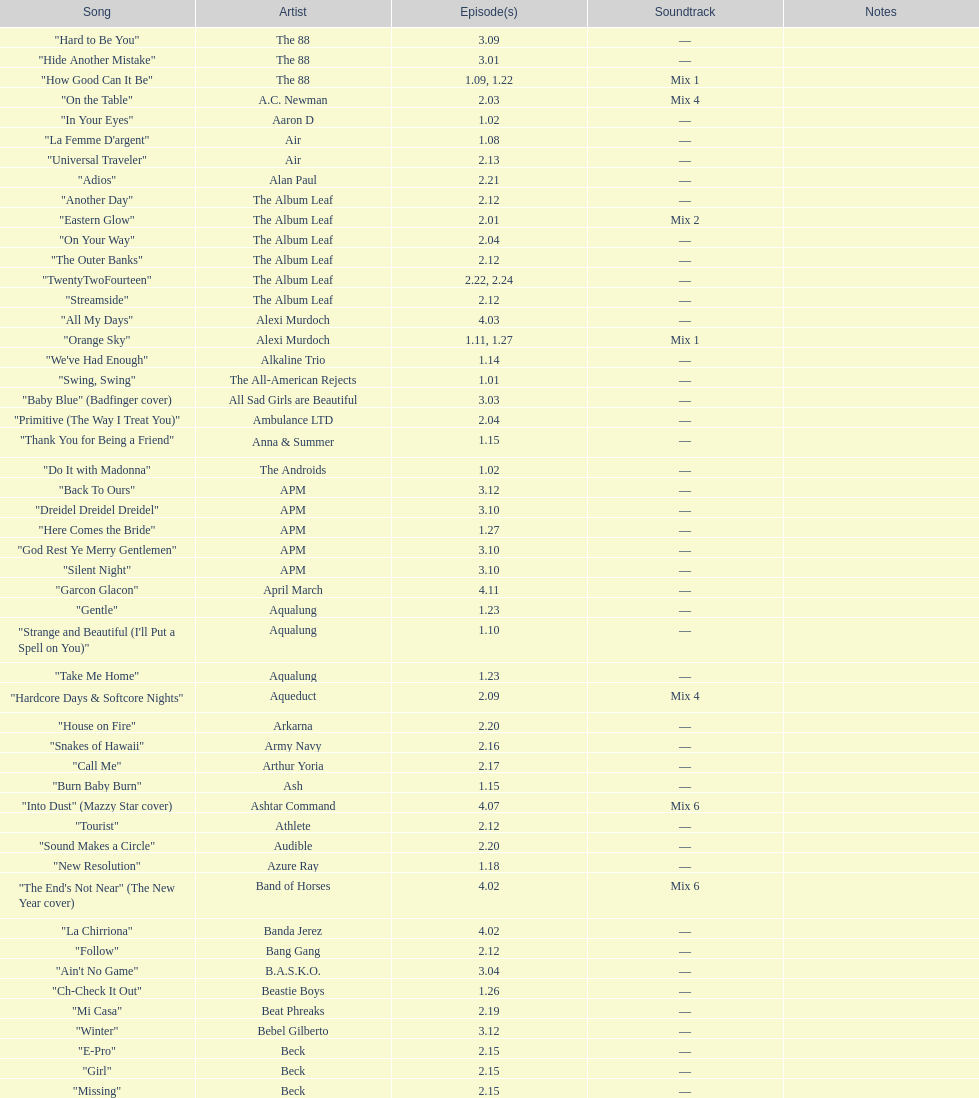How many episodes are below 2.00? 27. 